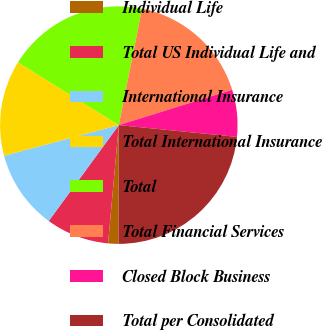Convert chart to OTSL. <chart><loc_0><loc_0><loc_500><loc_500><pie_chart><fcel>Individual Life<fcel>Total US Individual Life and<fcel>International Insurance<fcel>Total International Insurance<fcel>Total<fcel>Total Financial Services<fcel>Closed Block Business<fcel>Total per Consolidated<nl><fcel>1.4%<fcel>8.6%<fcel>10.81%<fcel>13.01%<fcel>19.27%<fcel>17.06%<fcel>6.39%<fcel>23.46%<nl></chart> 